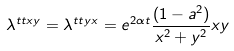<formula> <loc_0><loc_0><loc_500><loc_500>\lambda ^ { t t x y } = \lambda ^ { t t y x } = e ^ { 2 \alpha t } \frac { ( 1 - a ^ { 2 } ) } { x ^ { 2 } + y ^ { 2 } } x y</formula> 